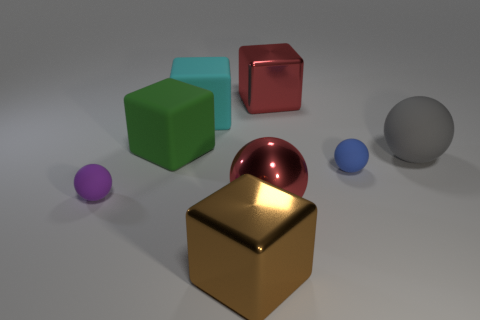Is there a blue matte ball?
Ensure brevity in your answer.  Yes. There is a big green matte block; are there any cyan matte things to the left of it?
Give a very brief answer. No. There is a large green thing that is the same shape as the big cyan thing; what is its material?
Provide a succinct answer. Rubber. Is there any other thing that has the same material as the large gray ball?
Offer a terse response. Yes. How many other things are there of the same shape as the brown shiny thing?
Provide a short and direct response. 3. There is a big ball on the left side of the red metal object that is behind the small purple sphere; how many blocks are to the left of it?
Offer a very short reply. 3. How many large metal objects are the same shape as the small blue rubber thing?
Give a very brief answer. 1. There is a large shiny object that is behind the purple matte sphere; is its color the same as the metal sphere?
Your answer should be compact. Yes. There is a large cyan thing in front of the metal block behind the big red thing in front of the big gray matte sphere; what shape is it?
Keep it short and to the point. Cube. There is a gray rubber object; is it the same size as the cube that is in front of the red metallic ball?
Offer a terse response. Yes. 